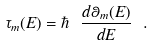Convert formula to latex. <formula><loc_0><loc_0><loc_500><loc_500>\tau _ { m } ( E ) = \hbar { \ } \frac { d \theta _ { m } ( E ) } { d E } \ .</formula> 